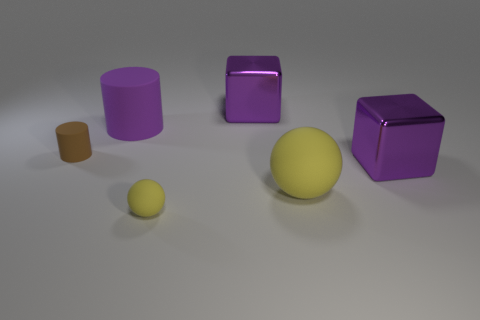Do the small matte sphere and the big matte sphere have the same color?
Offer a very short reply. Yes. The matte object that is the same color as the small rubber ball is what shape?
Your answer should be very brief. Sphere. There is a metal object that is behind the big rubber cylinder; does it have the same color as the big cylinder?
Make the answer very short. Yes. There is a large matte object that is behind the purple metallic thing in front of the big matte cylinder; what is its shape?
Your response must be concise. Cylinder. What number of objects are either cylinders that are right of the small brown object or yellow matte objects that are behind the small yellow rubber thing?
Offer a very short reply. 2. There is a large purple object that is made of the same material as the small sphere; what shape is it?
Your answer should be very brief. Cylinder. Are there any other things that are the same color as the big ball?
Your answer should be compact. Yes. There is a tiny brown object that is the same shape as the big purple matte object; what material is it?
Provide a succinct answer. Rubber. What number of other things are there of the same size as the purple cylinder?
Offer a very short reply. 3. What is the material of the large yellow sphere?
Keep it short and to the point. Rubber. 